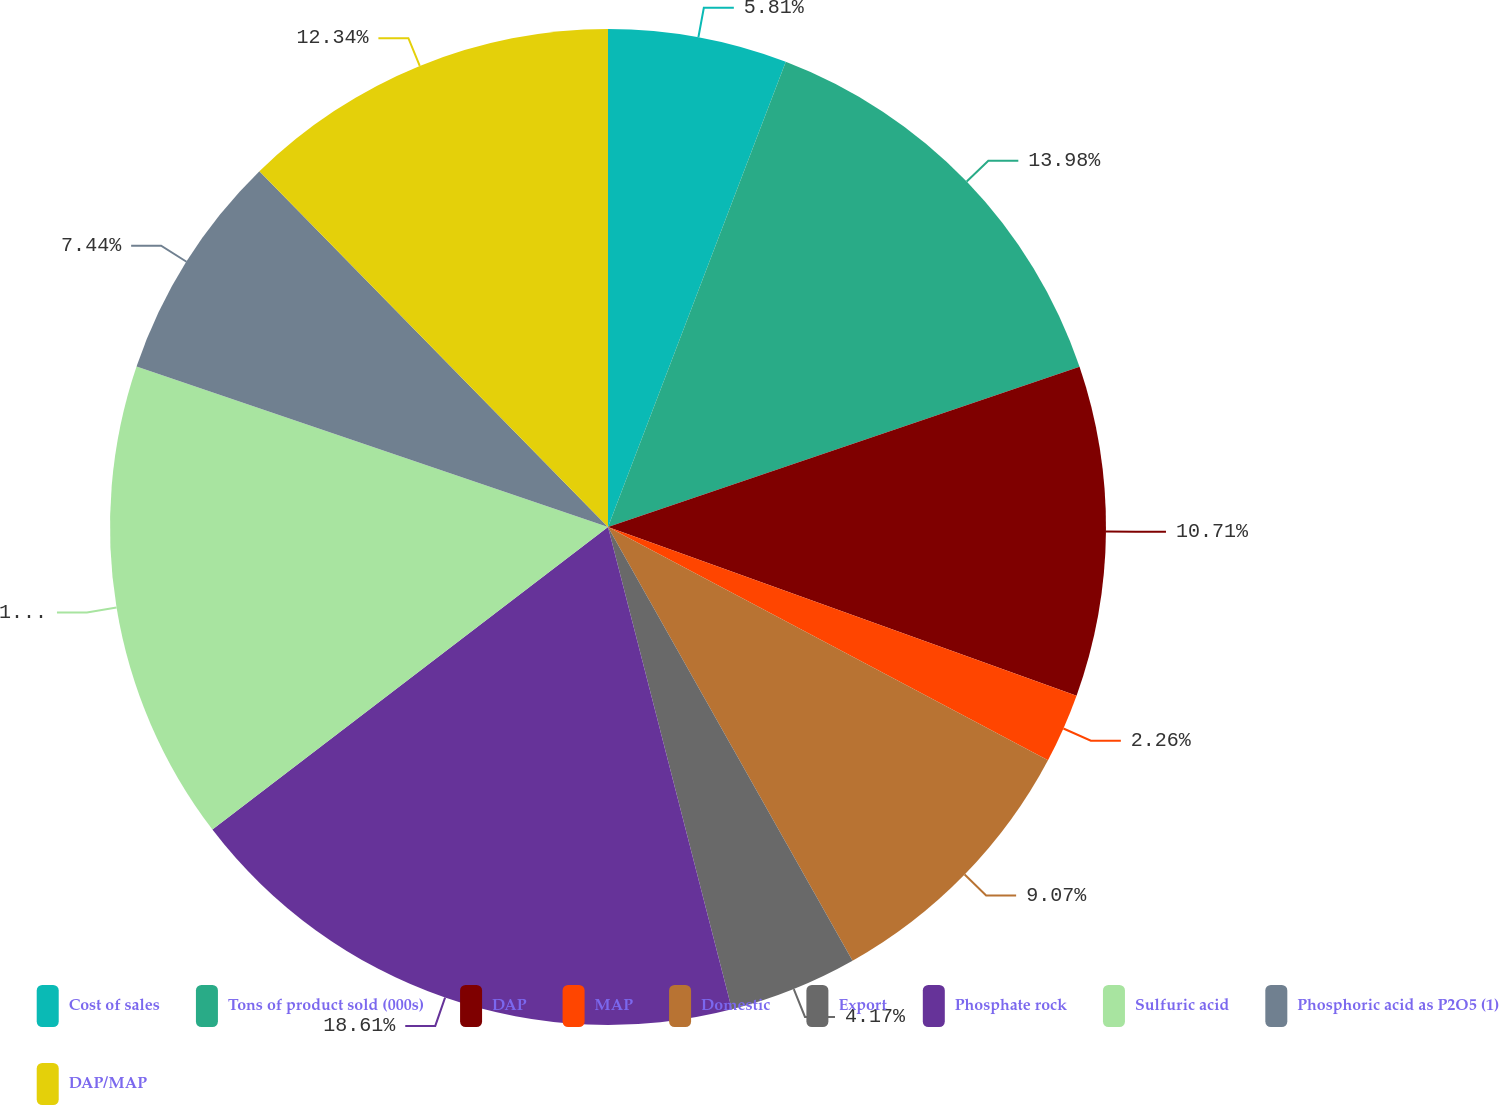Convert chart. <chart><loc_0><loc_0><loc_500><loc_500><pie_chart><fcel>Cost of sales<fcel>Tons of product sold (000s)<fcel>DAP<fcel>MAP<fcel>Domestic<fcel>Export<fcel>Phosphate rock<fcel>Sulfuric acid<fcel>Phosphoric acid as P2O5 (1)<fcel>DAP/MAP<nl><fcel>5.81%<fcel>13.98%<fcel>10.71%<fcel>2.26%<fcel>9.07%<fcel>4.17%<fcel>18.61%<fcel>15.61%<fcel>7.44%<fcel>12.34%<nl></chart> 